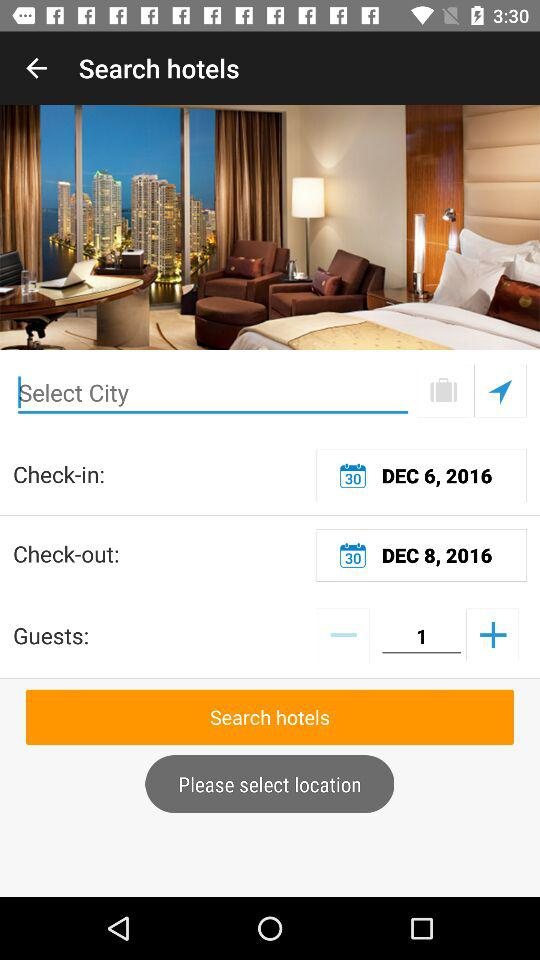How many guests are shown? The shown guest is 1. 